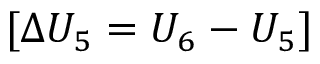<formula> <loc_0><loc_0><loc_500><loc_500>[ \Delta U _ { 5 } = U _ { 6 } - U _ { 5 } ]</formula> 